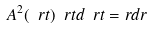Convert formula to latex. <formula><loc_0><loc_0><loc_500><loc_500>A ^ { 2 } ( \ r t ) \ r t d \ r t = r d r</formula> 